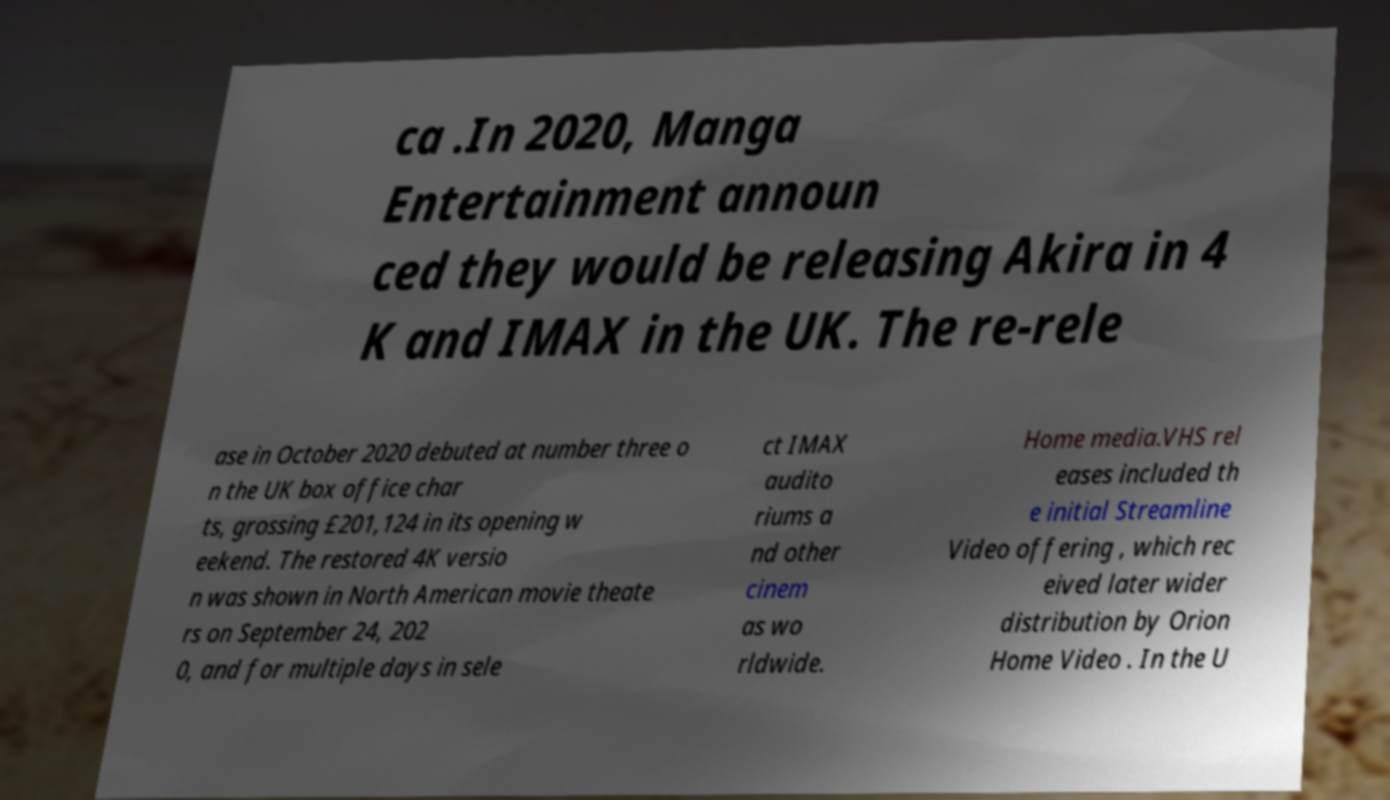There's text embedded in this image that I need extracted. Can you transcribe it verbatim? ca .In 2020, Manga Entertainment announ ced they would be releasing Akira in 4 K and IMAX in the UK. The re-rele ase in October 2020 debuted at number three o n the UK box office char ts, grossing £201,124 in its opening w eekend. The restored 4K versio n was shown in North American movie theate rs on September 24, 202 0, and for multiple days in sele ct IMAX audito riums a nd other cinem as wo rldwide. Home media.VHS rel eases included th e initial Streamline Video offering , which rec eived later wider distribution by Orion Home Video . In the U 